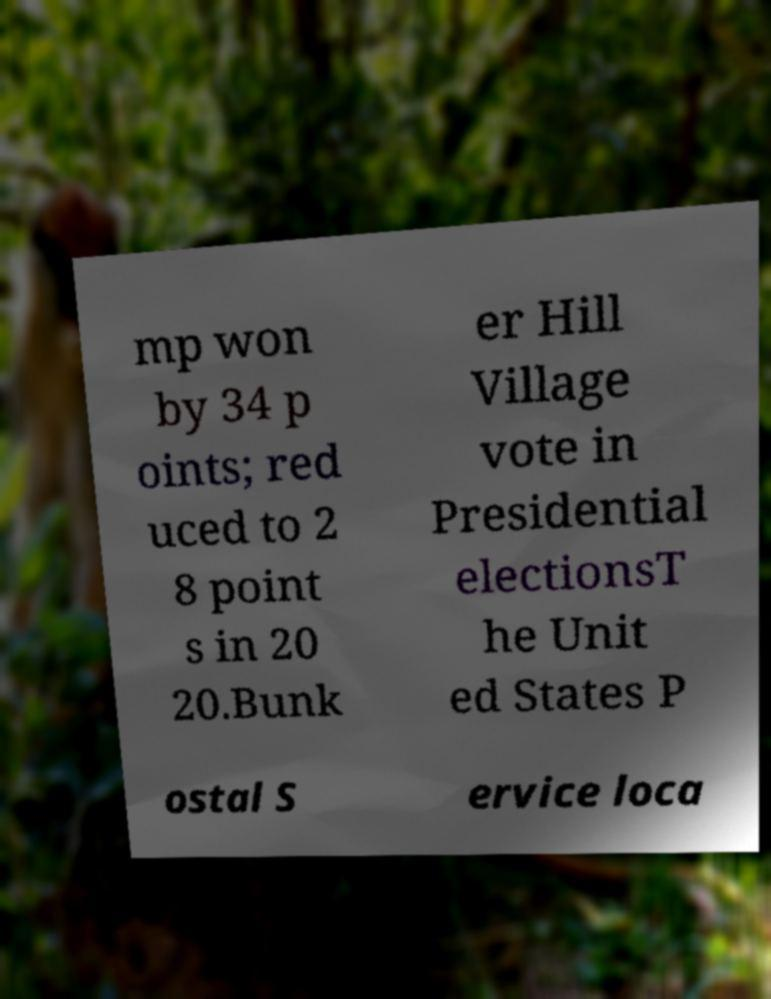Please identify and transcribe the text found in this image. mp won by 34 p oints; red uced to 2 8 point s in 20 20.Bunk er Hill Village vote in Presidential electionsT he Unit ed States P ostal S ervice loca 